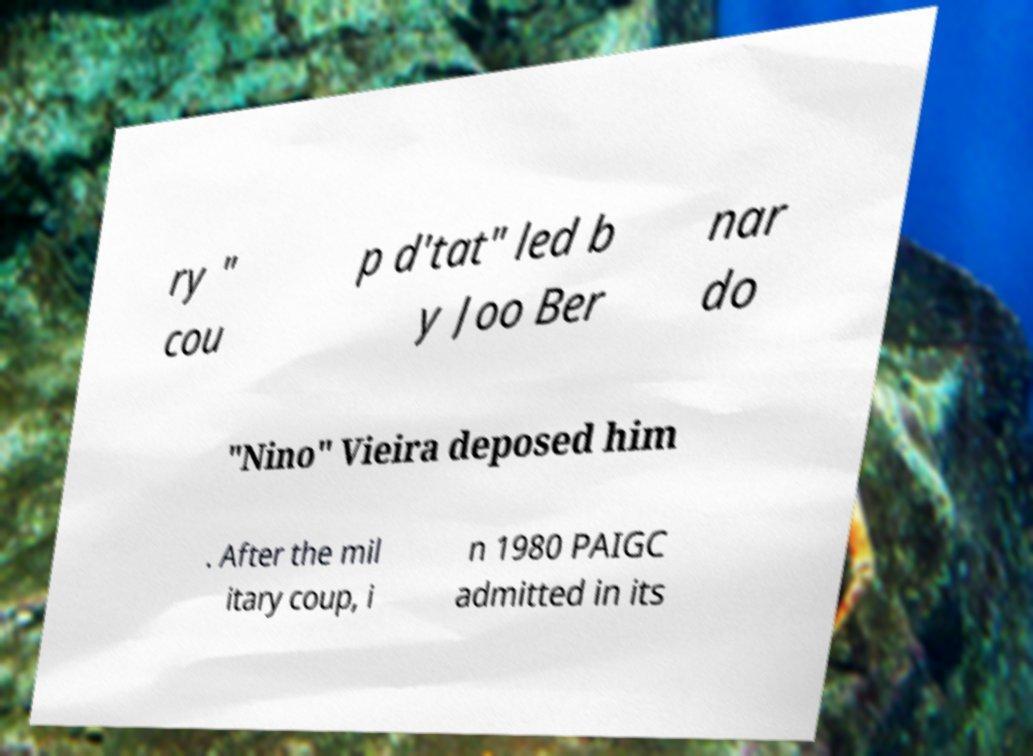Could you assist in decoding the text presented in this image and type it out clearly? ry " cou p d'tat" led b y Joo Ber nar do "Nino" Vieira deposed him . After the mil itary coup, i n 1980 PAIGC admitted in its 